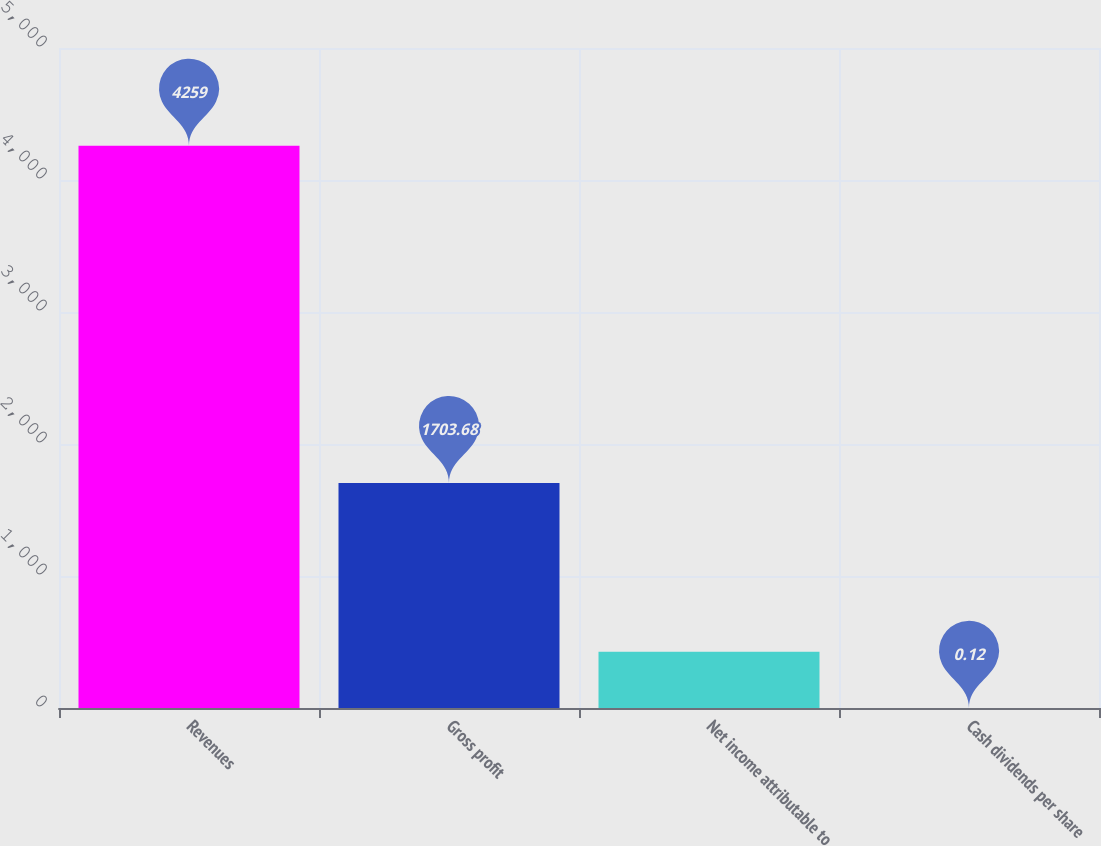Convert chart to OTSL. <chart><loc_0><loc_0><loc_500><loc_500><bar_chart><fcel>Revenues<fcel>Gross profit<fcel>Net income attributable to<fcel>Cash dividends per share<nl><fcel>4259<fcel>1703.68<fcel>426.01<fcel>0.12<nl></chart> 